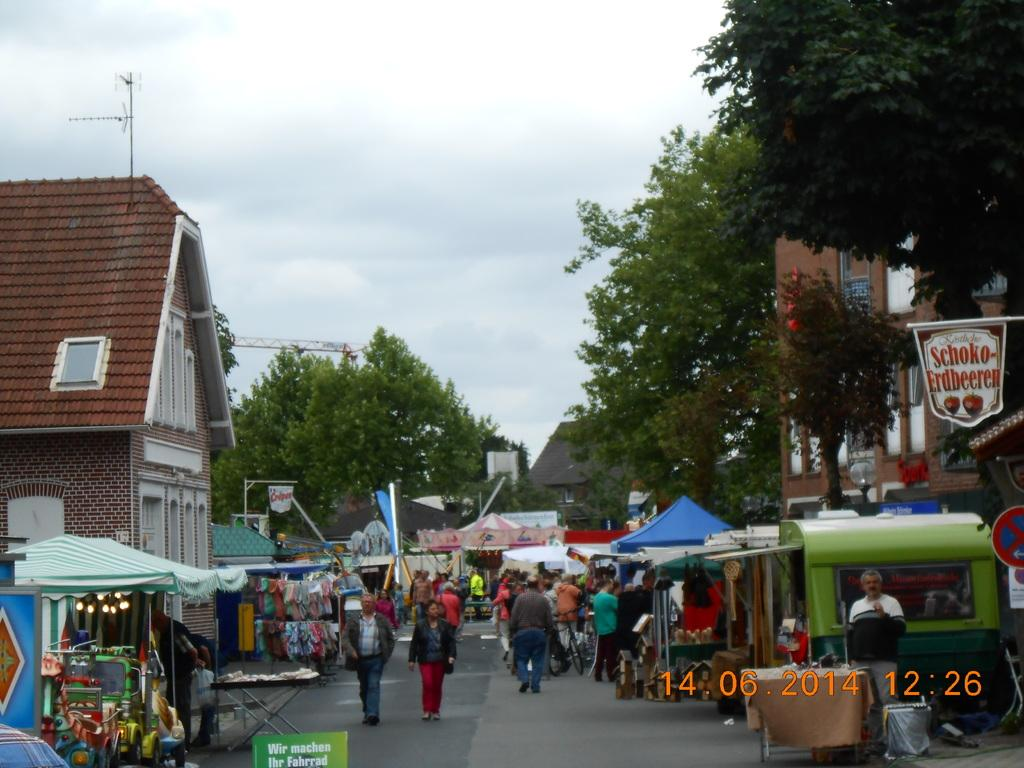What type of structures can be seen in the image? There are stalls in the image. Are there any people in the image? Yes, people are present in the image. What can be seen in the background of the image? There are trees and buildings in the background of the image. What is the purpose of the sign board in the image? The purpose of the sign board is not specified, but it may provide information or directions. What additional information is provided at the bottom of the image? The date and time are mentioned at the bottom of the image. What type of shoes are the fish wearing in the image? There are no fish or shoes present in the image. What color is the suit worn by the person in the image? There is no person wearing a suit in the image. 